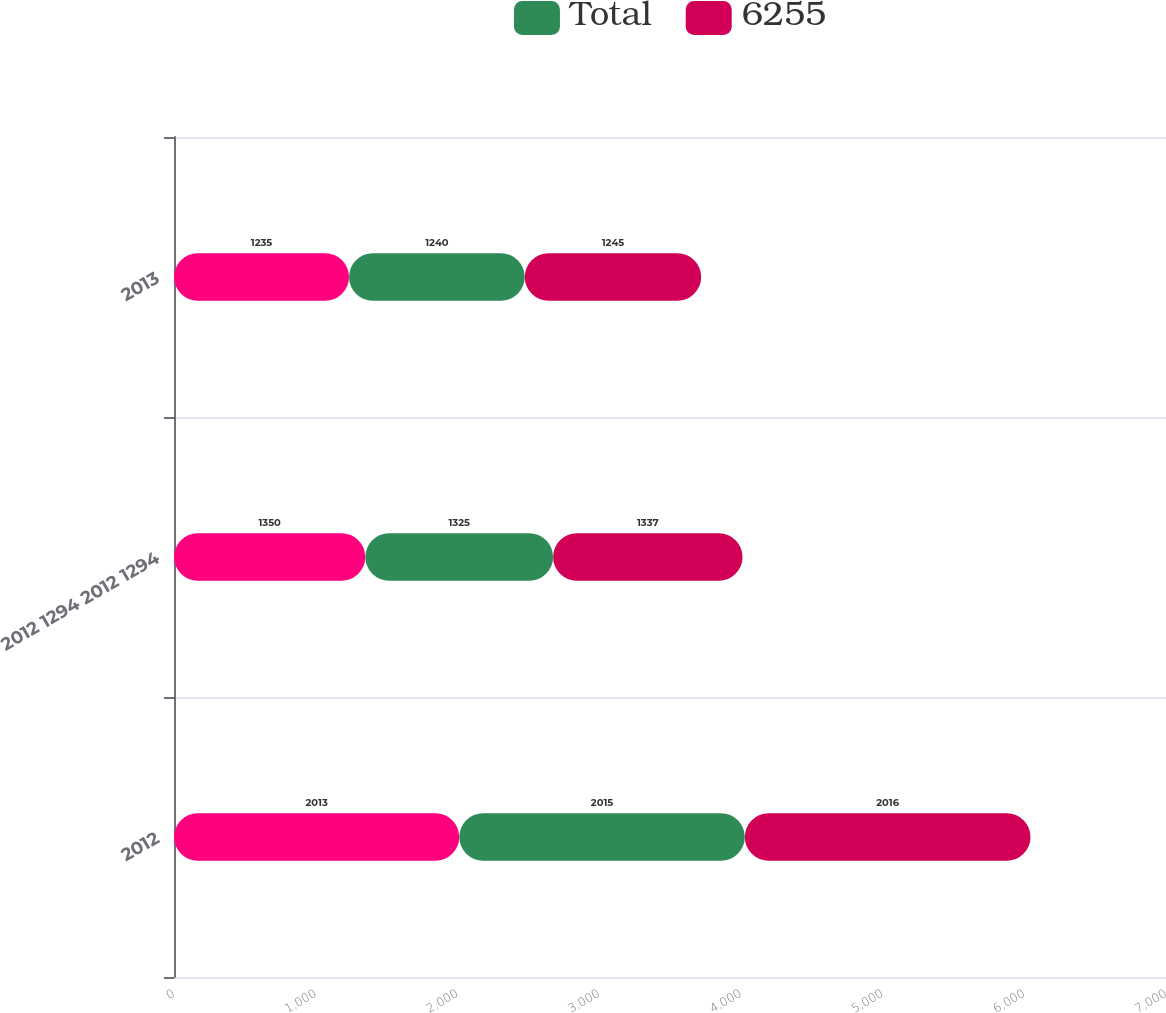Convert chart to OTSL. <chart><loc_0><loc_0><loc_500><loc_500><stacked_bar_chart><ecel><fcel>2012<fcel>2012 1294 2012 1294<fcel>2013<nl><fcel>nan<fcel>2013<fcel>1350<fcel>1235<nl><fcel>Total<fcel>2015<fcel>1325<fcel>1240<nl><fcel>6255<fcel>2016<fcel>1337<fcel>1245<nl></chart> 